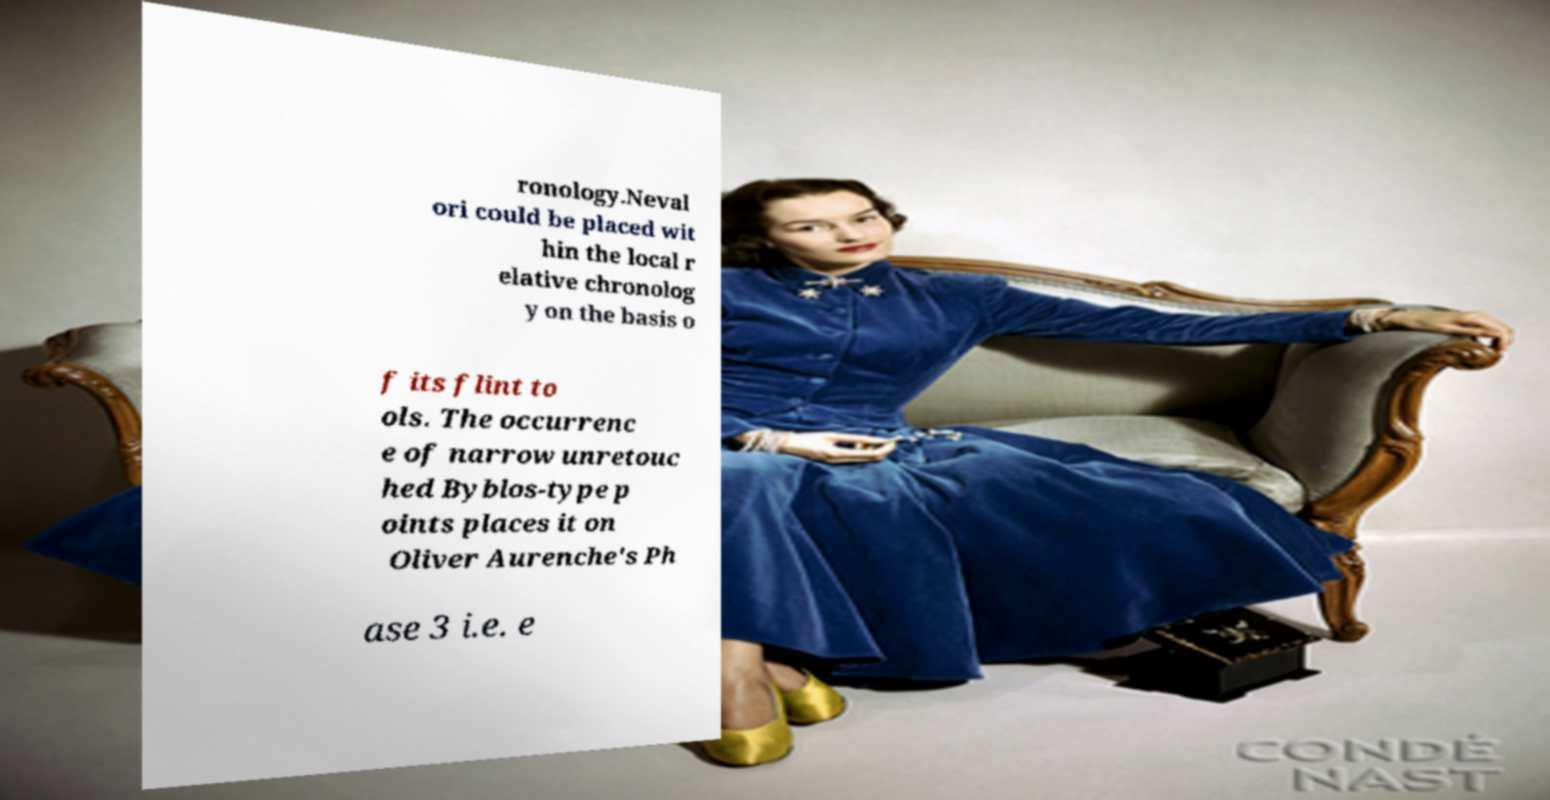Could you assist in decoding the text presented in this image and type it out clearly? ronology.Neval ori could be placed wit hin the local r elative chronolog y on the basis o f its flint to ols. The occurrenc e of narrow unretouc hed Byblos-type p oints places it on Oliver Aurenche's Ph ase 3 i.e. e 